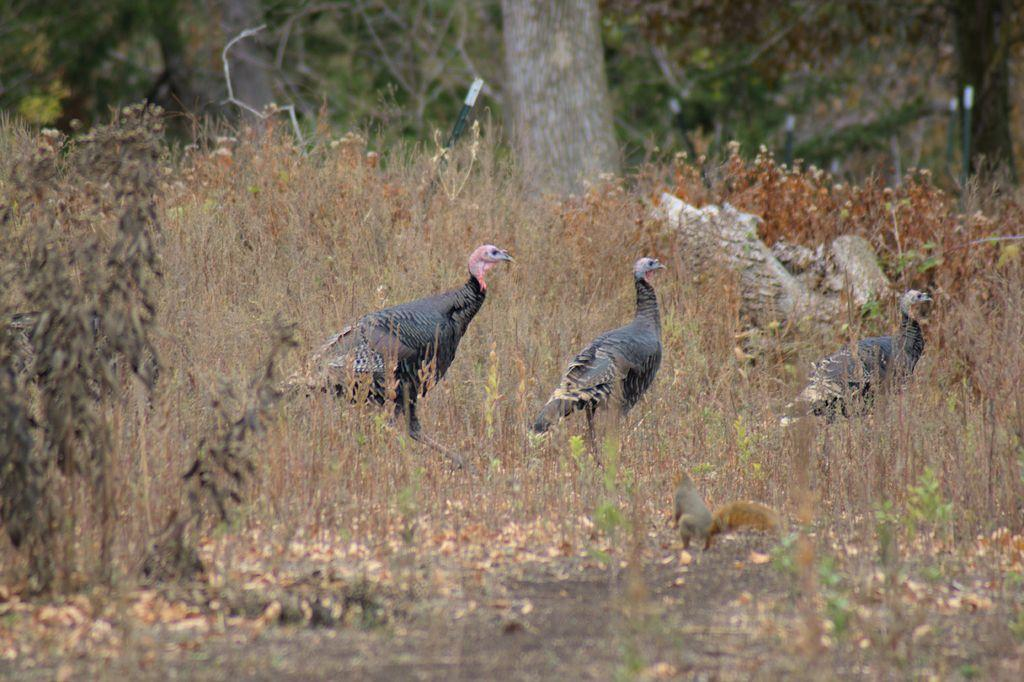How many birds can be seen in the image? There are three birds in the image. What other animal is present in the image besides the birds? A: There is an animal that looks like a squirrel in the image. What type of vegetation can be seen in the background of the image? There are plants and trees in the background of the image. Can you see any bones sticking out of the bird's wound in the image? There is no bird with a wound in the image, and therefore no bones are visible. 